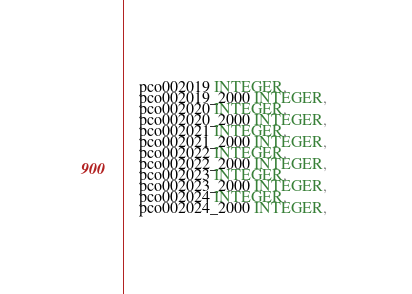<code> <loc_0><loc_0><loc_500><loc_500><_SQL_>	pco002019 INTEGER, 
	pco002019_2000 INTEGER, 
	pco002020 INTEGER, 
	pco002020_2000 INTEGER, 
	pco002021 INTEGER, 
	pco002021_2000 INTEGER, 
	pco002022 INTEGER, 
	pco002022_2000 INTEGER, 
	pco002023 INTEGER, 
	pco002023_2000 INTEGER, 
	pco002024 INTEGER, 
	pco002024_2000 INTEGER, </code> 